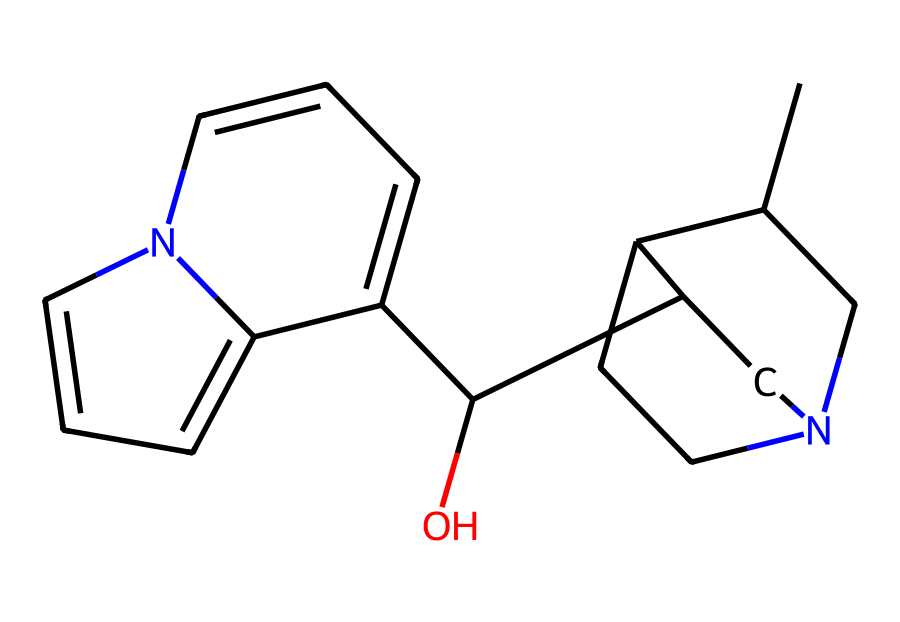What is the molecular formula of quinine? To determine the molecular formula, we can count the atoms of each element present in the compound based on the SMILES representation. The SMILES indicates there are carbon (C), hydrogen (H), oxygen (O), and nitrogen (N) atoms. The complete molecular formula after counting is C20H24N2O2.
Answer: C20H24N2O2 How many rings are present in the quinine structure? By analyzing the SMILES representation, we can identify the rings in the molecular structure. The structure presents interconnected cycles, and upon careful examination, we find there are three distinct rings present.
Answer: 3 Which type of functional group is present in quinine? Looking at the structure, we can identify various functional groups. The presence of an -OH group indicates that this molecule contains a hydroxyl functional group, which is significant in its properties.
Answer: hydroxyl What aspect of quinine's structure contributes to its medicinal properties? Quinine’s structure contains a specific arrangement of carbon, nitrogen, and oxygen atoms, including the nitrogen atoms embedded in the rings. These features are crucial as they interact with biological receptors, allowing quinine to effectively exhibit its antimalarial properties.
Answer: nitrogen atoms How does the presence of nitrogen affect the properties of quinine? Nitrogen atoms in quinine contribute to its classification as an alkaloid, which typically imparts specific pharmacological properties. Alkaloids often affect the central nervous system, and the nitrogen contributes to the bitter taste, which is notable in quinine.
Answer: bitter taste What is the significance of the stereochemistry in quinine? The stereochemistry in quinine plays a crucial role in its biological activity. The specific 3D arrangement of atoms in quinine allows it to fit into specific enzyme sites in malaria-causing parasites, thus affecting its efficacy as an antimalarial agent.
Answer: biological activity 